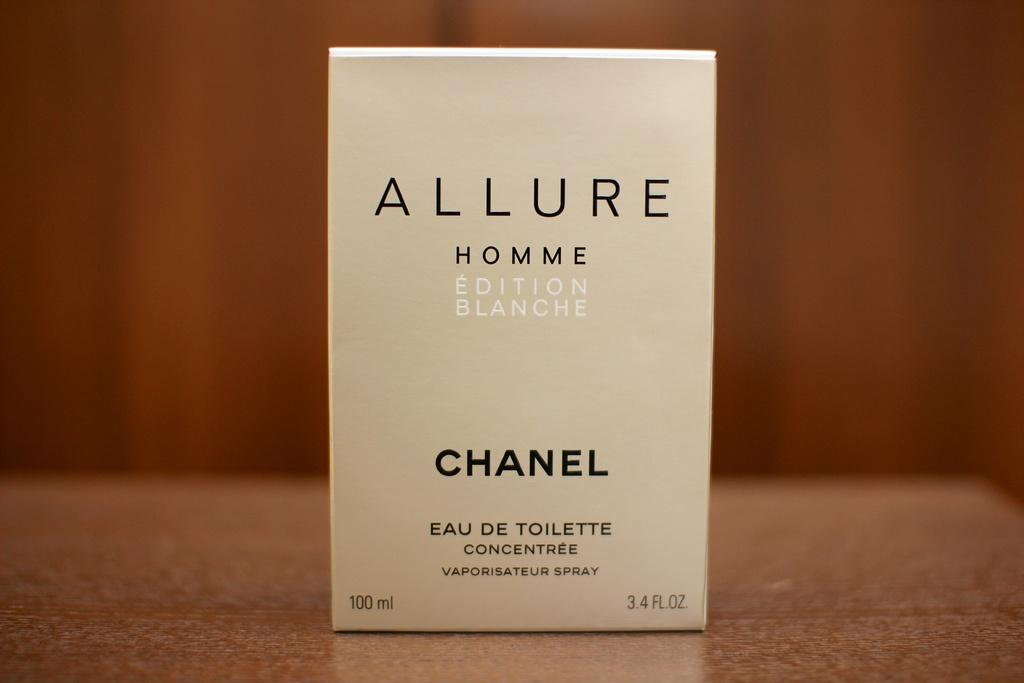What is the color of the box in the image? The box is white in color. Where is the box located in the image? The box is on a table. What can be found on the box? There is writing on the box. What is the color of the table in the image? The table is brown in color. What type of club is being used to destroy the box in the image? There is no club or destruction present in the image; the box is simply sitting on a table with writing on it. 